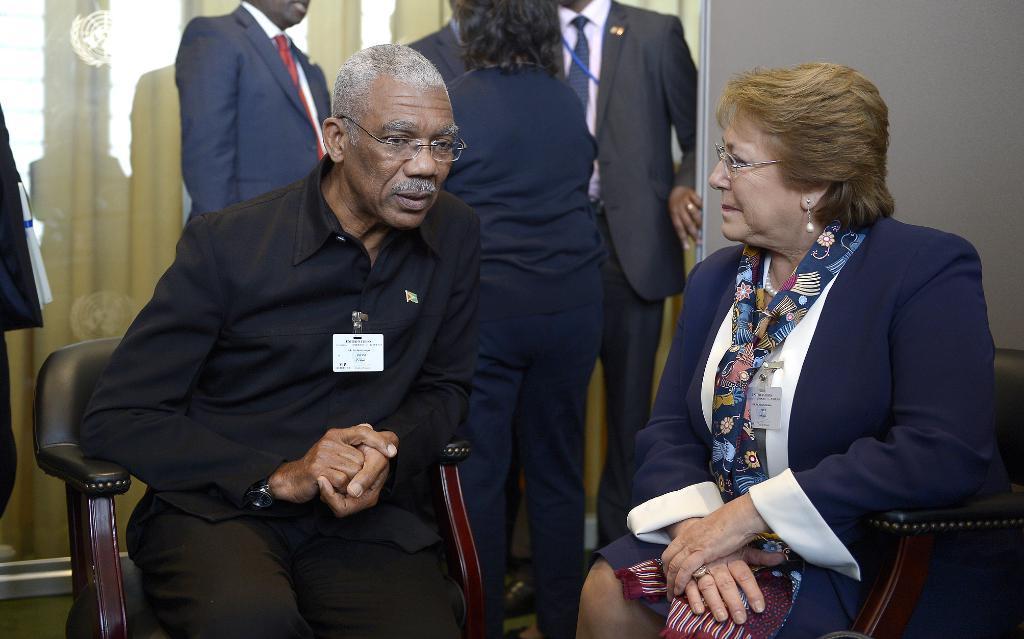Describe this image in one or two sentences. In this picture we can see men wore spectacle talking to the beside woman wore scarf, spectacle they both are sitting on chairs and at back of them some persons are standing. 